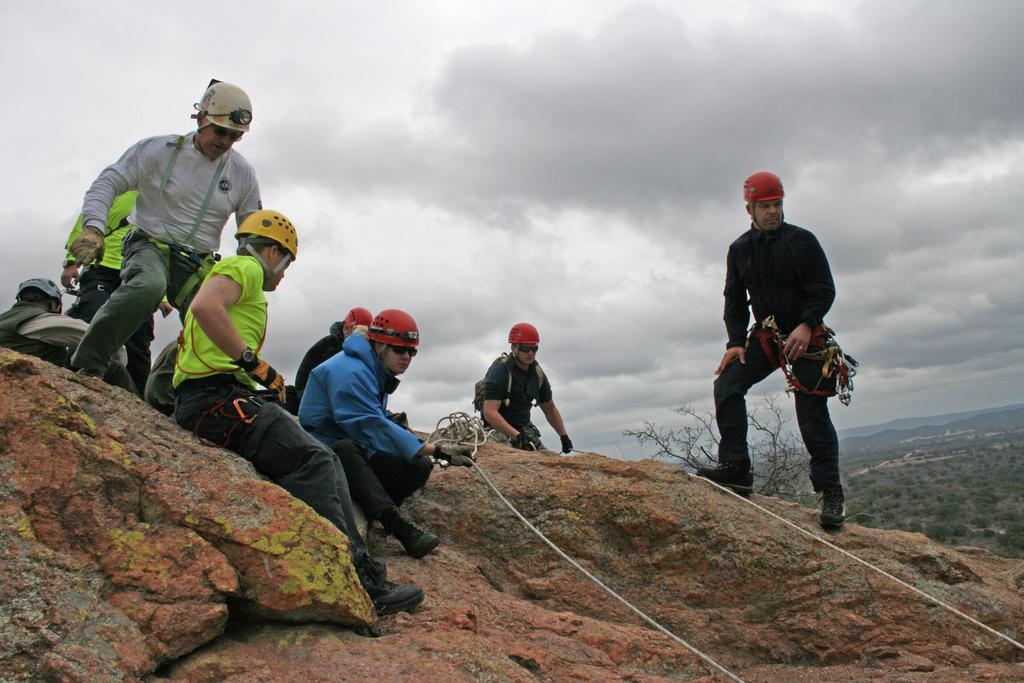How would you summarize this image in a sentence or two? In this image I can see people, ropes, rock surface, areas and cloudy sky. One person is holding a rope. Near that person there are objects. 